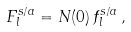Convert formula to latex. <formula><loc_0><loc_0><loc_500><loc_500>F _ { l } ^ { s / a } = N ( 0 ) \, f _ { l } ^ { s / a } \, ,</formula> 